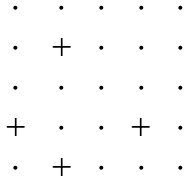Convert formula to latex. <formula><loc_0><loc_0><loc_500><loc_500>\begin{matrix} \, \cdot \, & \, \cdot \, & \, \cdot \, & \, \cdot \, & \, \cdot \, \\ \, \cdot \, & \, + \, & \, \cdot \, & \, \cdot \, & \, \cdot \, \\ \, \cdot \, & \, \cdot \, & \, \cdot \, & \, \cdot \, & \, \cdot \, \\ \, + \, & \, \cdot \, & \, \cdot \, & \, + \, & \, \cdot \, \\ \, \cdot \, & \, + \, & \, \cdot \, & \, \cdot \, & \, \cdot \, \\ \end{matrix}</formula> 